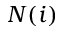Convert formula to latex. <formula><loc_0><loc_0><loc_500><loc_500>N ( i )</formula> 